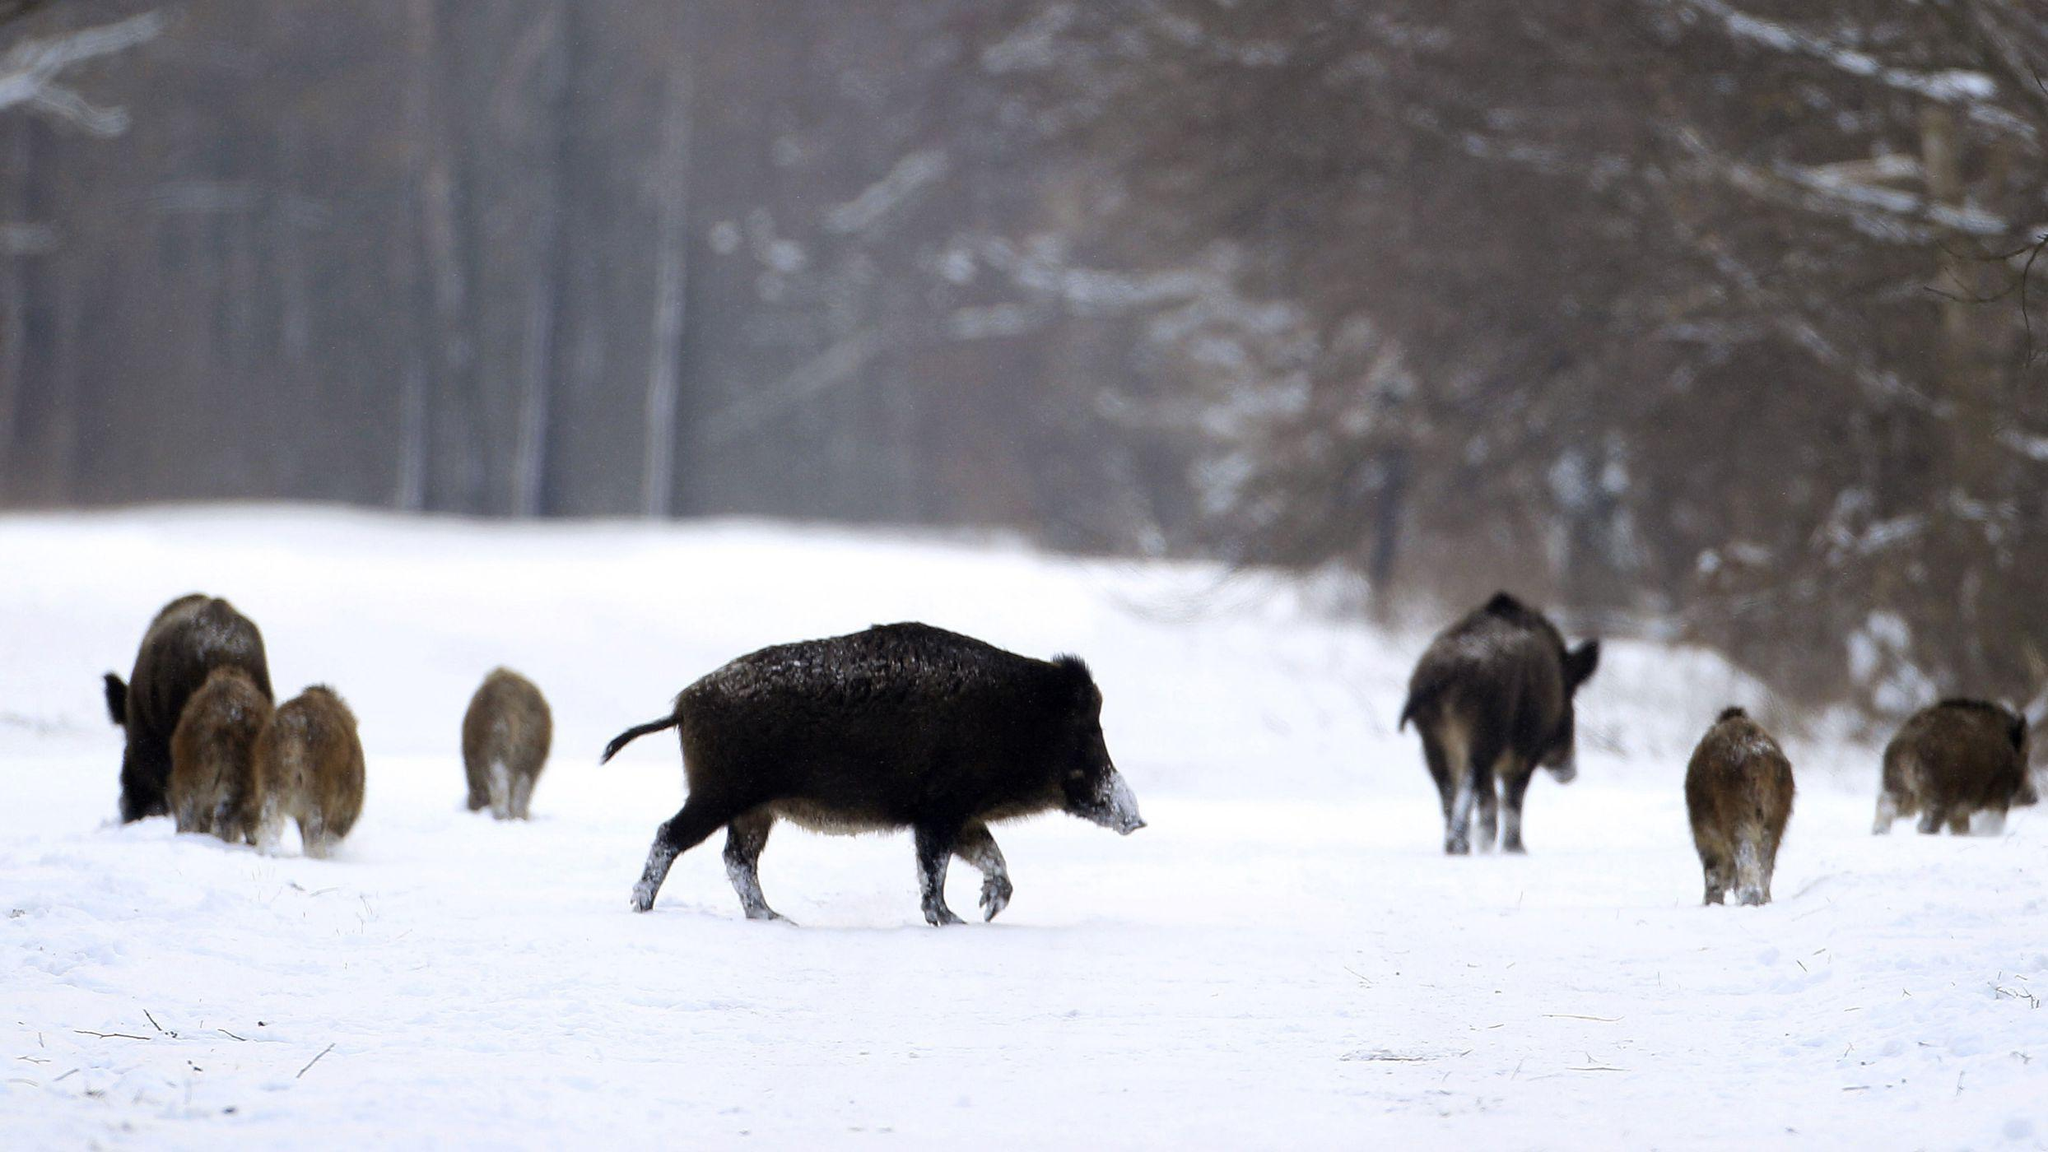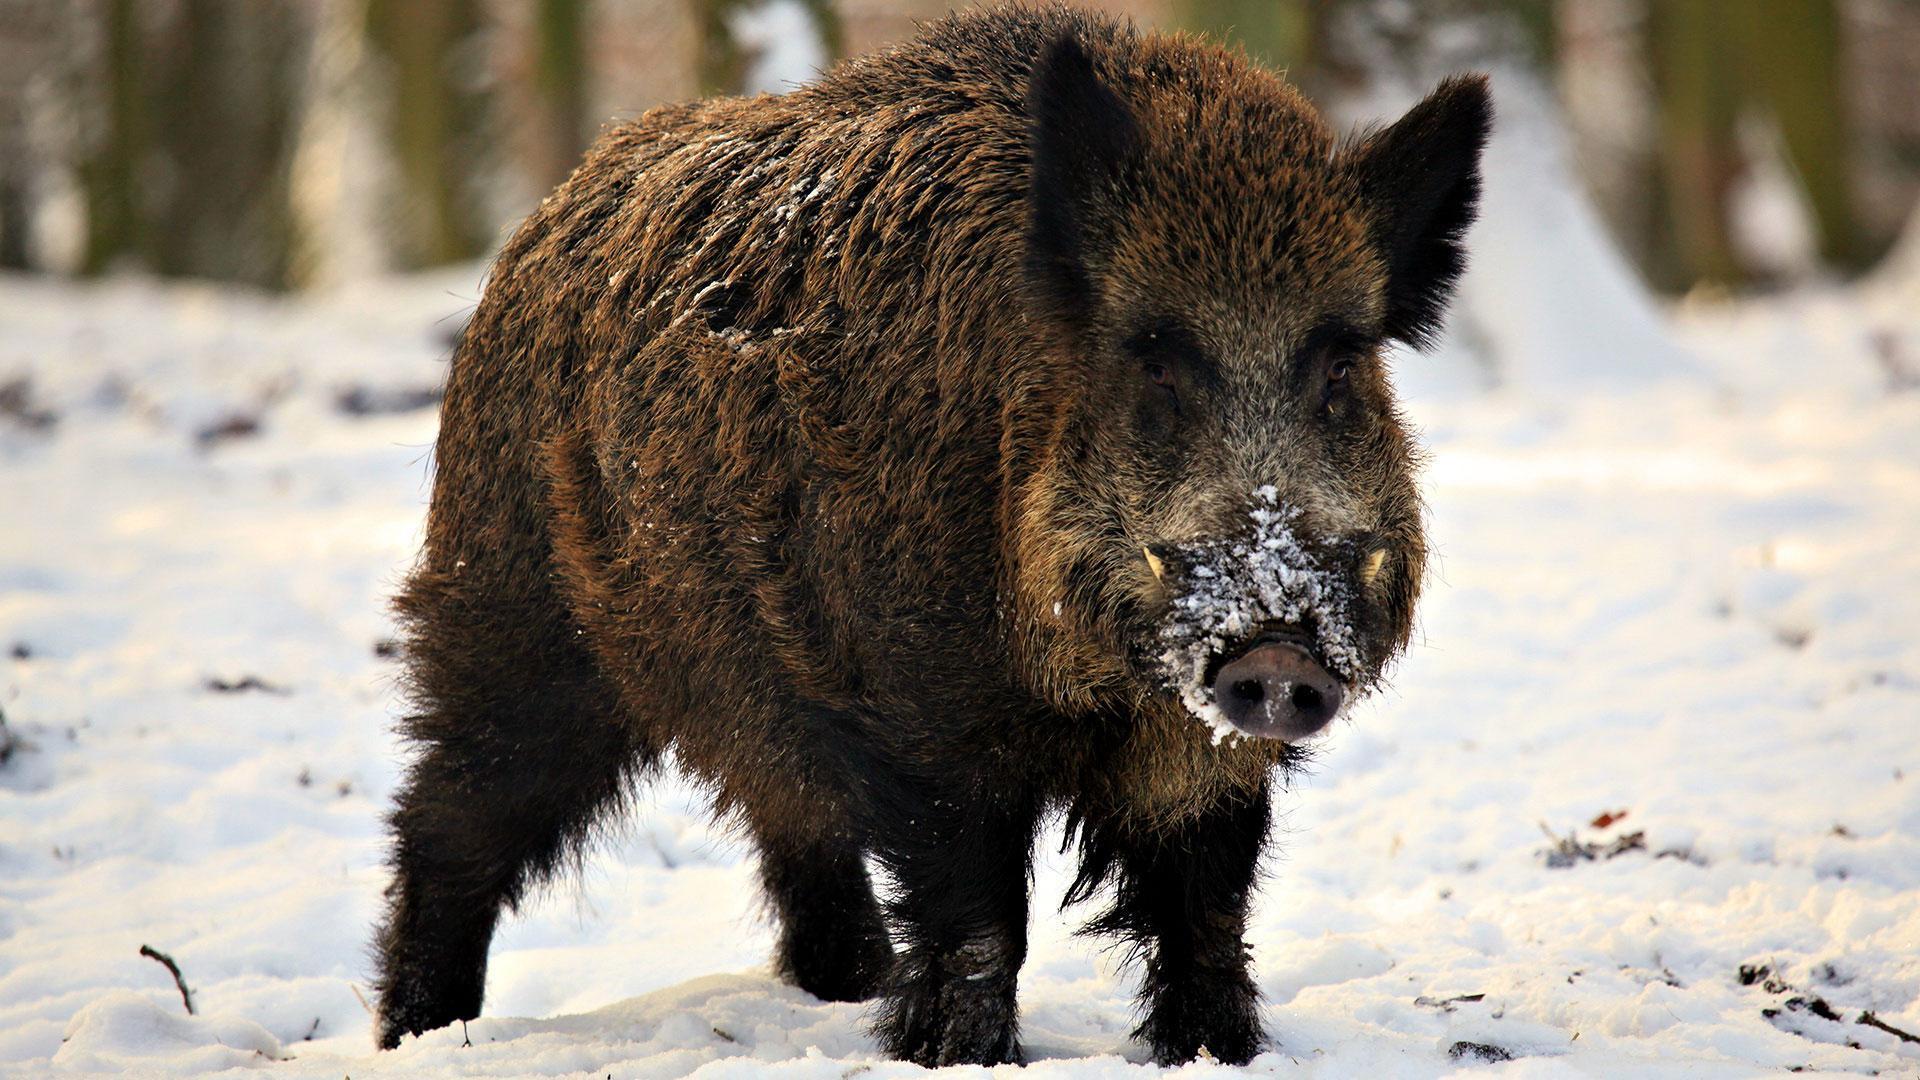The first image is the image on the left, the second image is the image on the right. For the images shown, is this caption "there is exactly one adult boar in one of the images" true? Answer yes or no. Yes. 